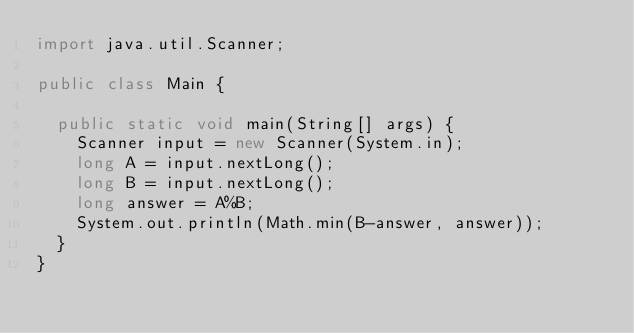Convert code to text. <code><loc_0><loc_0><loc_500><loc_500><_Java_>import java.util.Scanner;

public class Main {

	public static void main(String[] args) {
		Scanner input = new Scanner(System.in);
		long A = input.nextLong();
		long B = input.nextLong();
		long answer = A%B;
		System.out.println(Math.min(B-answer, answer));
	}
}</code> 